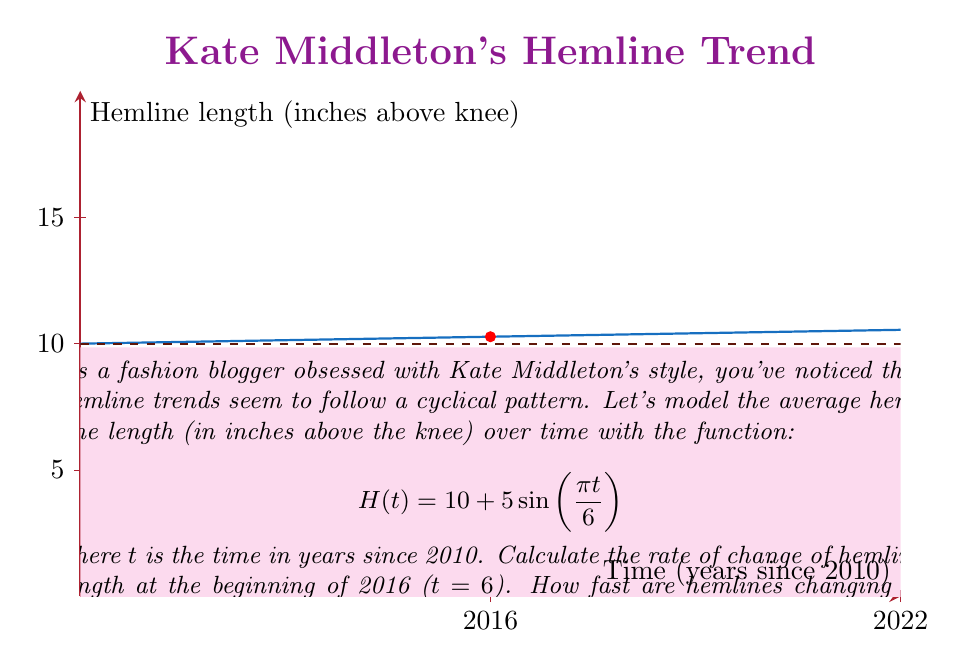Solve this math problem. To find the rate of change of hemline length at t = 6, we need to calculate the derivative of H(t) and evaluate it at t = 6.

Step 1: Find the derivative of H(t)
$$H(t) = 10 + 5\sin(\frac{\pi t}{6})$$
$$H'(t) = 5 \cdot \frac{\pi}{6} \cos(\frac{\pi t}{6}) = \frac{5\pi}{6} \cos(\frac{\pi t}{6})$$

Step 2: Evaluate H'(t) at t = 6
$$H'(6) = \frac{5\pi}{6} \cos(\frac{\pi \cdot 6}{6}) = \frac{5\pi}{6} \cos(\pi) = -\frac{5\pi}{6} \approx -2.618$$

Step 3: Interpret the result
The rate of change at t = 6 (beginning of 2016) is approximately -2.618 inches per year. The negative value indicates that hemlines are getting shorter at this point in time.

To put this in fashion terms, Kate Middleton's hemlines would be trending about 2.6 inches shorter per year at the start of 2016 according to this model.
Answer: $-\frac{5\pi}{6}$ inches/year, shortening 